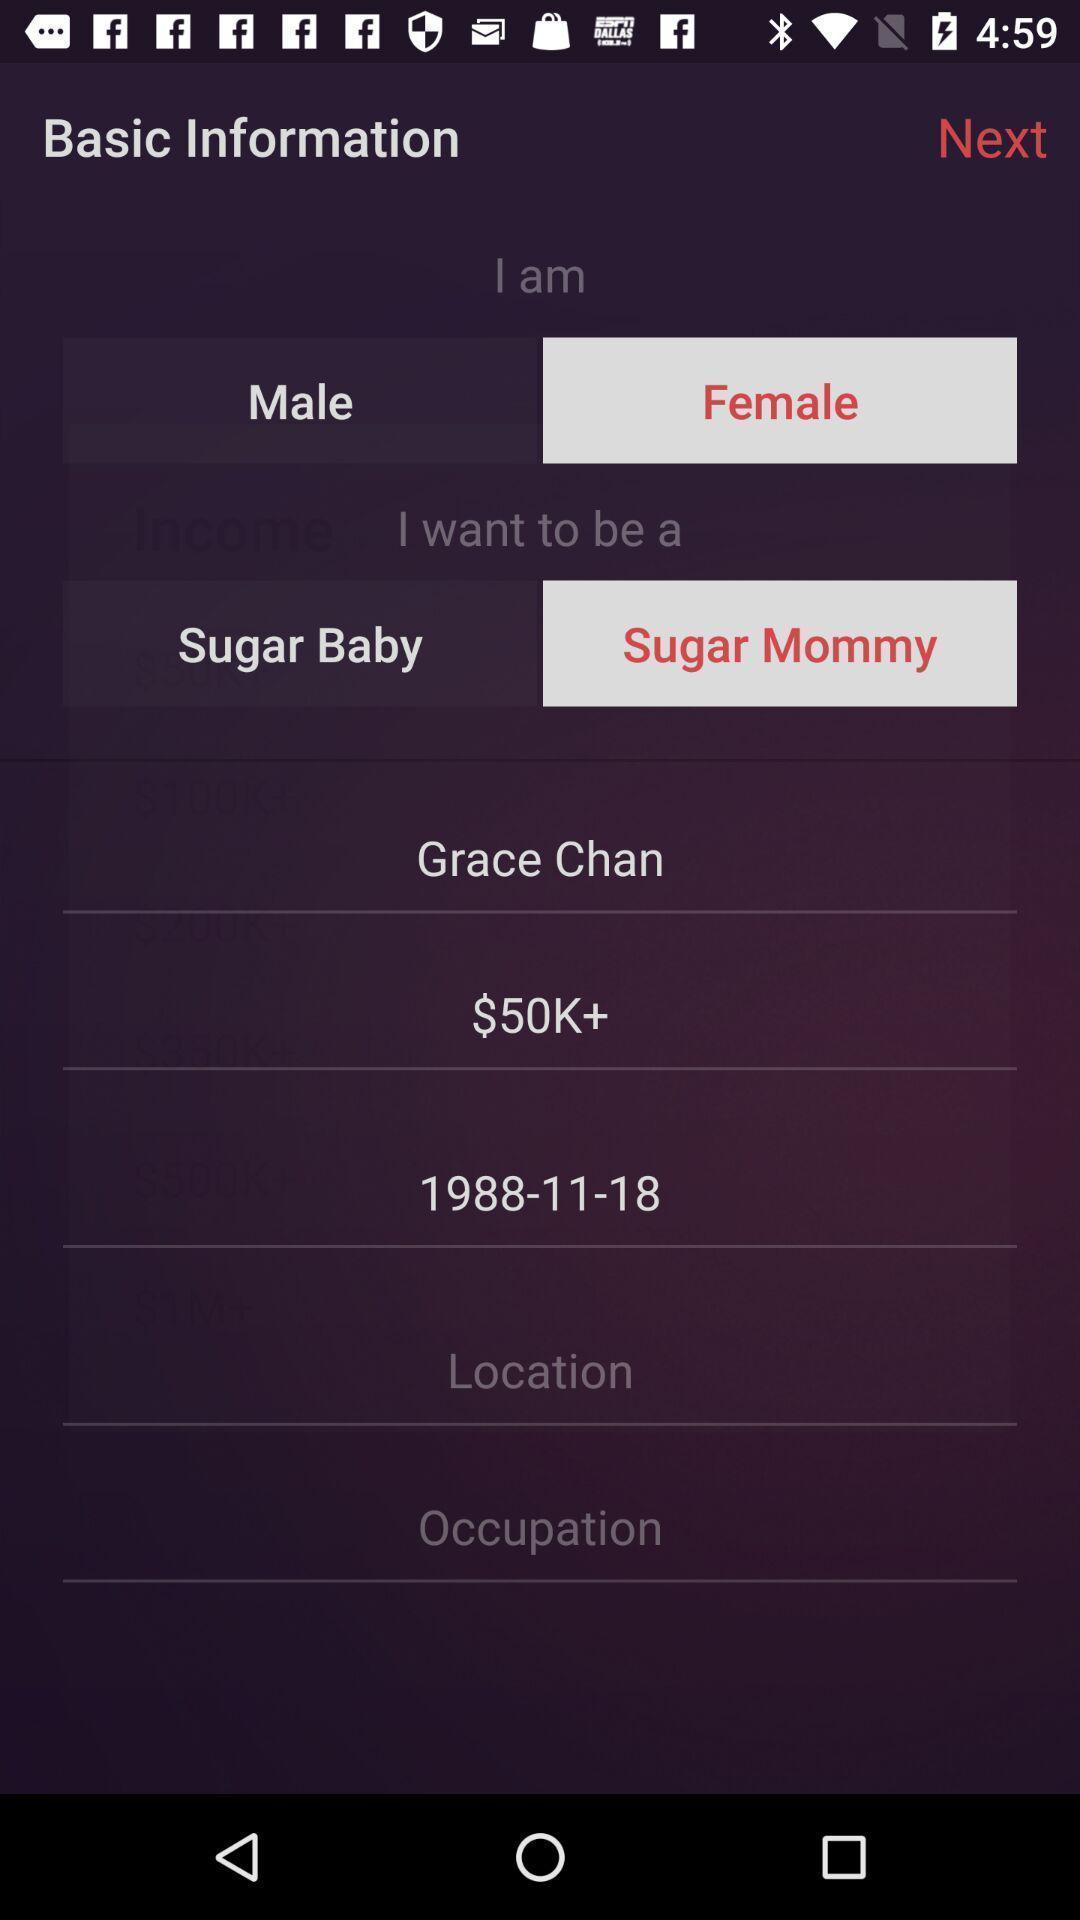What can you discern from this picture? Screen displaying basic information page. 